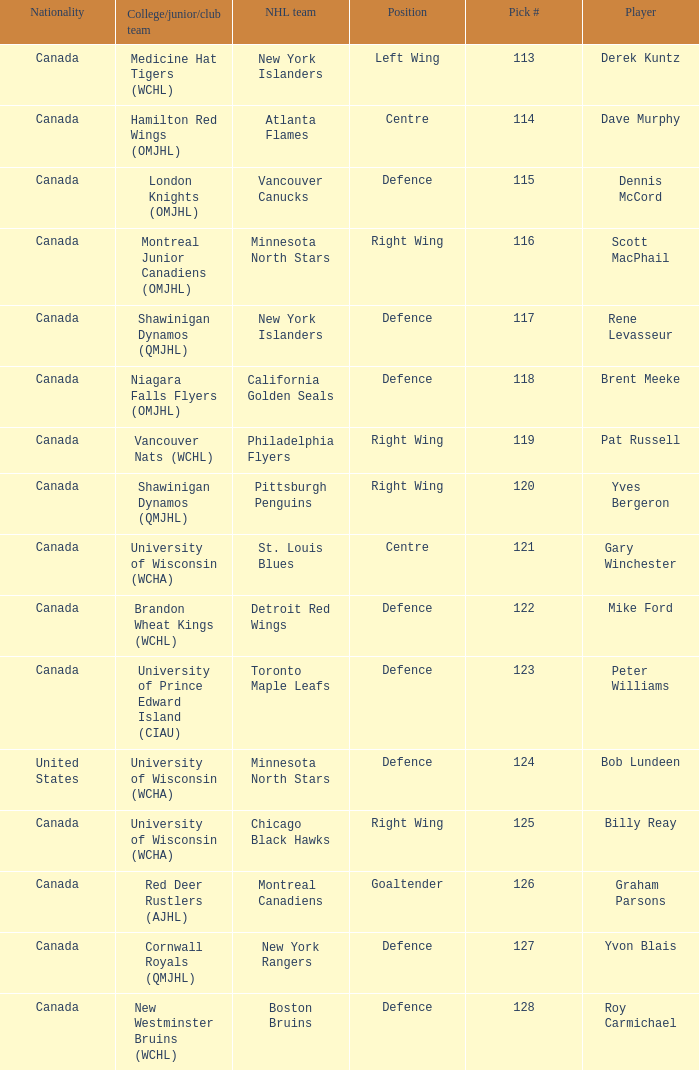Name the college/junior/club team for left wing Medicine Hat Tigers (WCHL). 